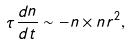Convert formula to latex. <formula><loc_0><loc_0><loc_500><loc_500>\tau \frac { d n } { d t } \sim - n \times n r ^ { 2 } ,</formula> 